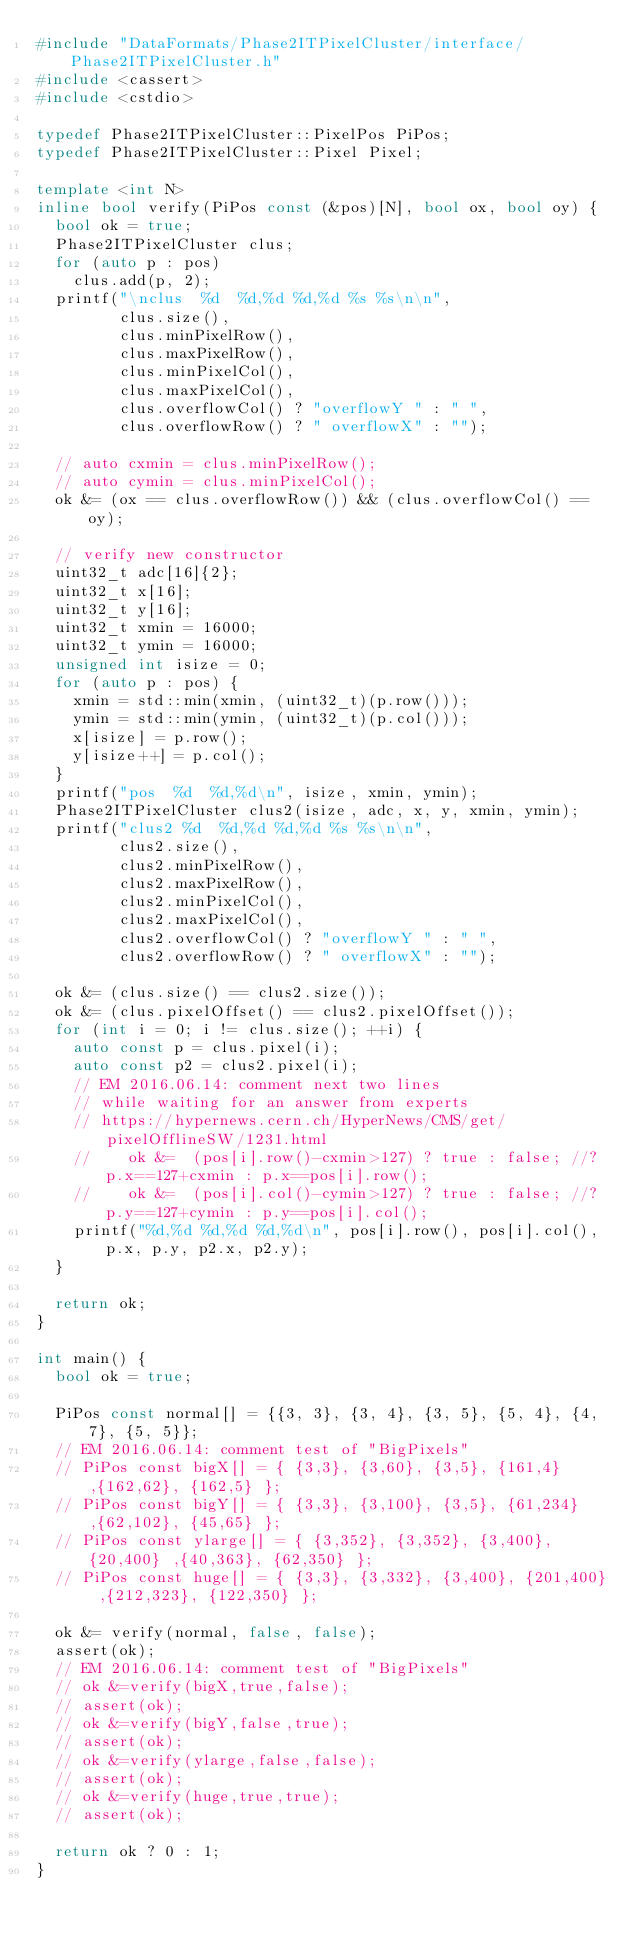Convert code to text. <code><loc_0><loc_0><loc_500><loc_500><_C++_>#include "DataFormats/Phase2ITPixelCluster/interface/Phase2ITPixelCluster.h"
#include <cassert>
#include <cstdio>

typedef Phase2ITPixelCluster::PixelPos PiPos;
typedef Phase2ITPixelCluster::Pixel Pixel;

template <int N>
inline bool verify(PiPos const (&pos)[N], bool ox, bool oy) {
  bool ok = true;
  Phase2ITPixelCluster clus;
  for (auto p : pos)
    clus.add(p, 2);
  printf("\nclus  %d  %d,%d %d,%d %s %s\n\n",
         clus.size(),
         clus.minPixelRow(),
         clus.maxPixelRow(),
         clus.minPixelCol(),
         clus.maxPixelCol(),
         clus.overflowCol() ? "overflowY " : " ",
         clus.overflowRow() ? " overflowX" : "");

  // auto cxmin = clus.minPixelRow();
  // auto cymin = clus.minPixelCol();
  ok &= (ox == clus.overflowRow()) && (clus.overflowCol() == oy);

  // verify new constructor
  uint32_t adc[16]{2};
  uint32_t x[16];
  uint32_t y[16];
  uint32_t xmin = 16000;
  uint32_t ymin = 16000;
  unsigned int isize = 0;
  for (auto p : pos) {
    xmin = std::min(xmin, (uint32_t)(p.row()));
    ymin = std::min(ymin, (uint32_t)(p.col()));
    x[isize] = p.row();
    y[isize++] = p.col();
  }
  printf("pos  %d  %d,%d\n", isize, xmin, ymin);
  Phase2ITPixelCluster clus2(isize, adc, x, y, xmin, ymin);
  printf("clus2 %d  %d,%d %d,%d %s %s\n\n",
         clus2.size(),
         clus2.minPixelRow(),
         clus2.maxPixelRow(),
         clus2.minPixelCol(),
         clus2.maxPixelCol(),
         clus2.overflowCol() ? "overflowY " : " ",
         clus2.overflowRow() ? " overflowX" : "");

  ok &= (clus.size() == clus2.size());
  ok &= (clus.pixelOffset() == clus2.pixelOffset());
  for (int i = 0; i != clus.size(); ++i) {
    auto const p = clus.pixel(i);
    auto const p2 = clus2.pixel(i);
    // EM 2016.06.14: comment next two lines
    // while waiting for an answer from experts
    // https://hypernews.cern.ch/HyperNews/CMS/get/pixelOfflineSW/1231.html
    //    ok &=  (pos[i].row()-cxmin>127) ? true : false; //? p.x==127+cxmin : p.x==pos[i].row();
    //    ok &=  (pos[i].col()-cymin>127) ? true : false; //? p.y==127+cymin : p.y==pos[i].col();
    printf("%d,%d %d,%d %d,%d\n", pos[i].row(), pos[i].col(), p.x, p.y, p2.x, p2.y);
  }

  return ok;
}

int main() {
  bool ok = true;

  PiPos const normal[] = {{3, 3}, {3, 4}, {3, 5}, {5, 4}, {4, 7}, {5, 5}};
  // EM 2016.06.14: comment test of "BigPixels"
  // PiPos const bigX[] = { {3,3}, {3,60}, {3,5}, {161,4} ,{162,62}, {162,5} };
  // PiPos const bigY[] = { {3,3}, {3,100}, {3,5}, {61,234} ,{62,102}, {45,65} };
  // PiPos const ylarge[] = { {3,352}, {3,352}, {3,400}, {20,400} ,{40,363}, {62,350} };
  // PiPos const huge[] = { {3,3}, {3,332}, {3,400}, {201,400} ,{212,323}, {122,350} };

  ok &= verify(normal, false, false);
  assert(ok);
  // EM 2016.06.14: comment test of "BigPixels"
  // ok &=verify(bigX,true,false);
  // assert(ok);
  // ok &=verify(bigY,false,true);
  // assert(ok);
  // ok &=verify(ylarge,false,false);
  // assert(ok);
  // ok &=verify(huge,true,true);
  // assert(ok);

  return ok ? 0 : 1;
}
</code> 